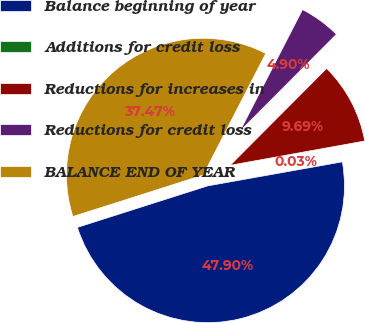Convert chart. <chart><loc_0><loc_0><loc_500><loc_500><pie_chart><fcel>Balance beginning of year<fcel>Additions for credit loss<fcel>Reductions for increases in<fcel>Reductions for credit loss<fcel>BALANCE END OF YEAR<nl><fcel>47.9%<fcel>0.03%<fcel>9.69%<fcel>4.9%<fcel>37.47%<nl></chart> 